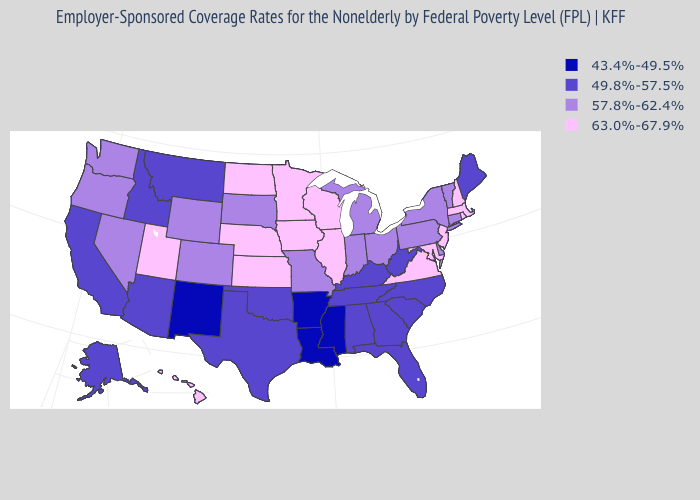Among the states that border Nebraska , which have the highest value?
Concise answer only. Iowa, Kansas. Which states have the highest value in the USA?
Concise answer only. Hawaii, Illinois, Iowa, Kansas, Maryland, Massachusetts, Minnesota, Nebraska, New Hampshire, New Jersey, North Dakota, Rhode Island, Utah, Virginia, Wisconsin. Does Oklahoma have a lower value than Colorado?
Answer briefly. Yes. Does Pennsylvania have a lower value than Wyoming?
Short answer required. No. What is the value of Wyoming?
Short answer required. 57.8%-62.4%. Does Ohio have a higher value than New York?
Quick response, please. No. Name the states that have a value in the range 57.8%-62.4%?
Concise answer only. Colorado, Connecticut, Delaware, Indiana, Michigan, Missouri, Nevada, New York, Ohio, Oregon, Pennsylvania, South Dakota, Vermont, Washington, Wyoming. Does the first symbol in the legend represent the smallest category?
Keep it brief. Yes. Does Maryland have a higher value than West Virginia?
Give a very brief answer. Yes. Name the states that have a value in the range 63.0%-67.9%?
Keep it brief. Hawaii, Illinois, Iowa, Kansas, Maryland, Massachusetts, Minnesota, Nebraska, New Hampshire, New Jersey, North Dakota, Rhode Island, Utah, Virginia, Wisconsin. Does the first symbol in the legend represent the smallest category?
Quick response, please. Yes. Name the states that have a value in the range 63.0%-67.9%?
Write a very short answer. Hawaii, Illinois, Iowa, Kansas, Maryland, Massachusetts, Minnesota, Nebraska, New Hampshire, New Jersey, North Dakota, Rhode Island, Utah, Virginia, Wisconsin. What is the value of North Dakota?
Keep it brief. 63.0%-67.9%. Does Iowa have the highest value in the MidWest?
Write a very short answer. Yes. Does the map have missing data?
Be succinct. No. 